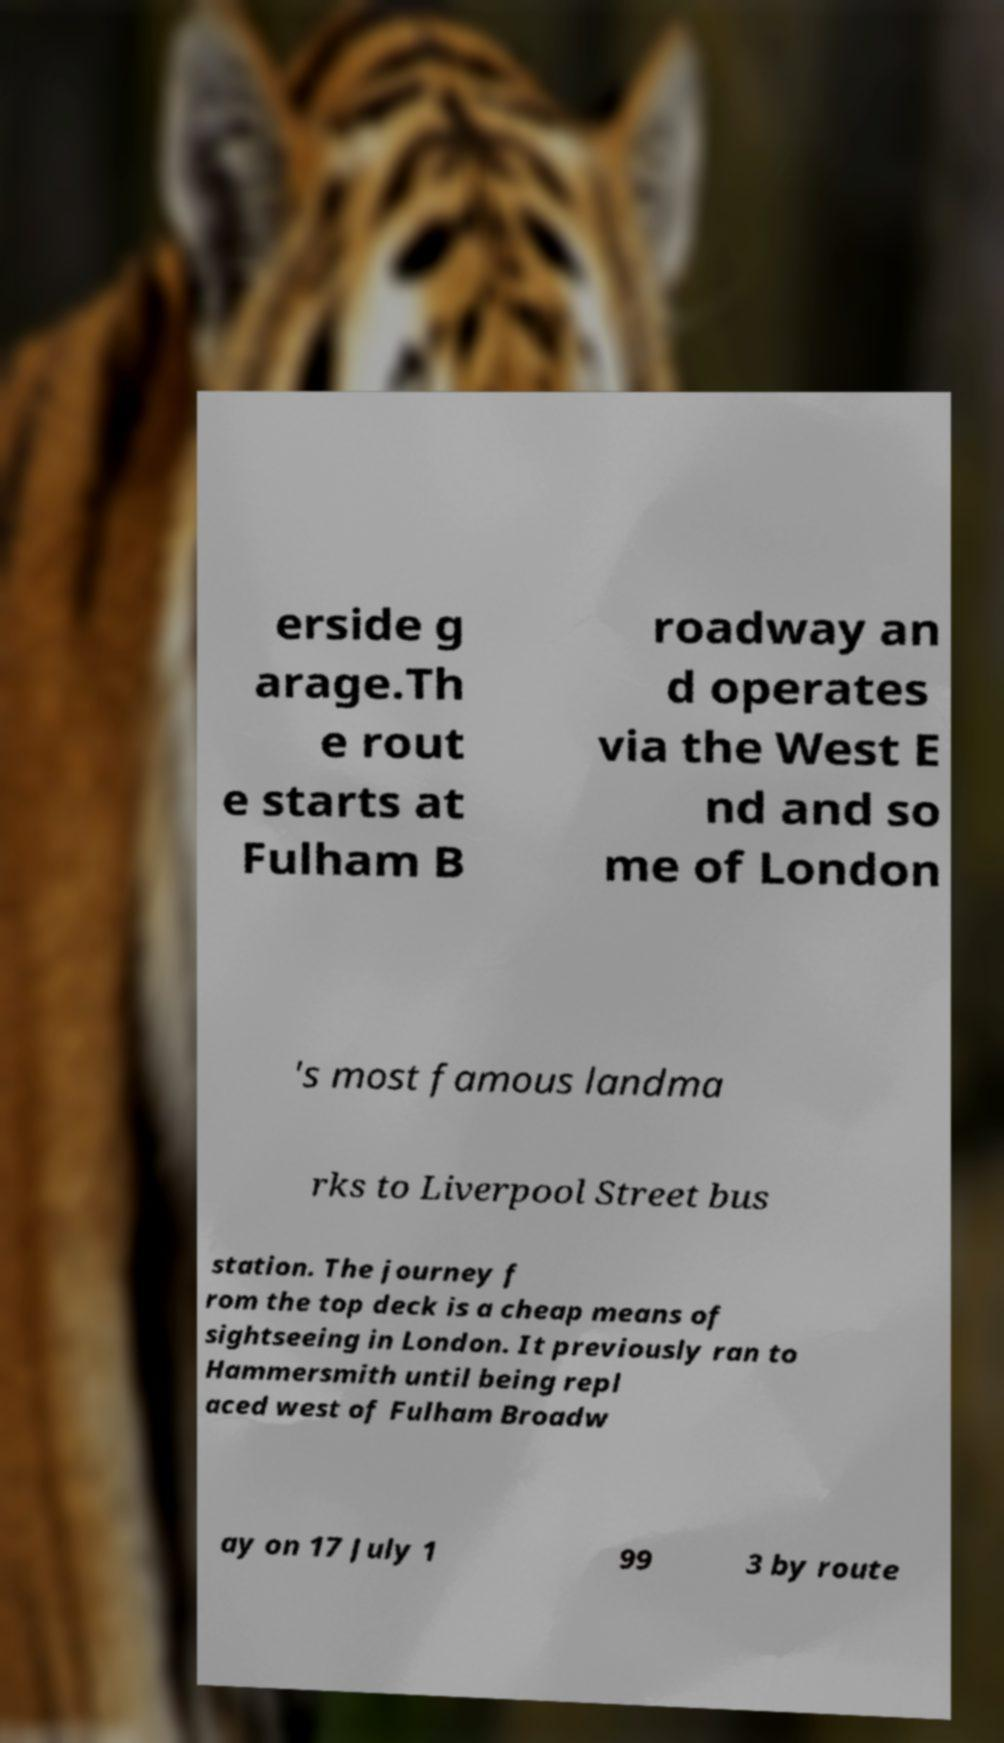Please identify and transcribe the text found in this image. erside g arage.Th e rout e starts at Fulham B roadway an d operates via the West E nd and so me of London 's most famous landma rks to Liverpool Street bus station. The journey f rom the top deck is a cheap means of sightseeing in London. It previously ran to Hammersmith until being repl aced west of Fulham Broadw ay on 17 July 1 99 3 by route 